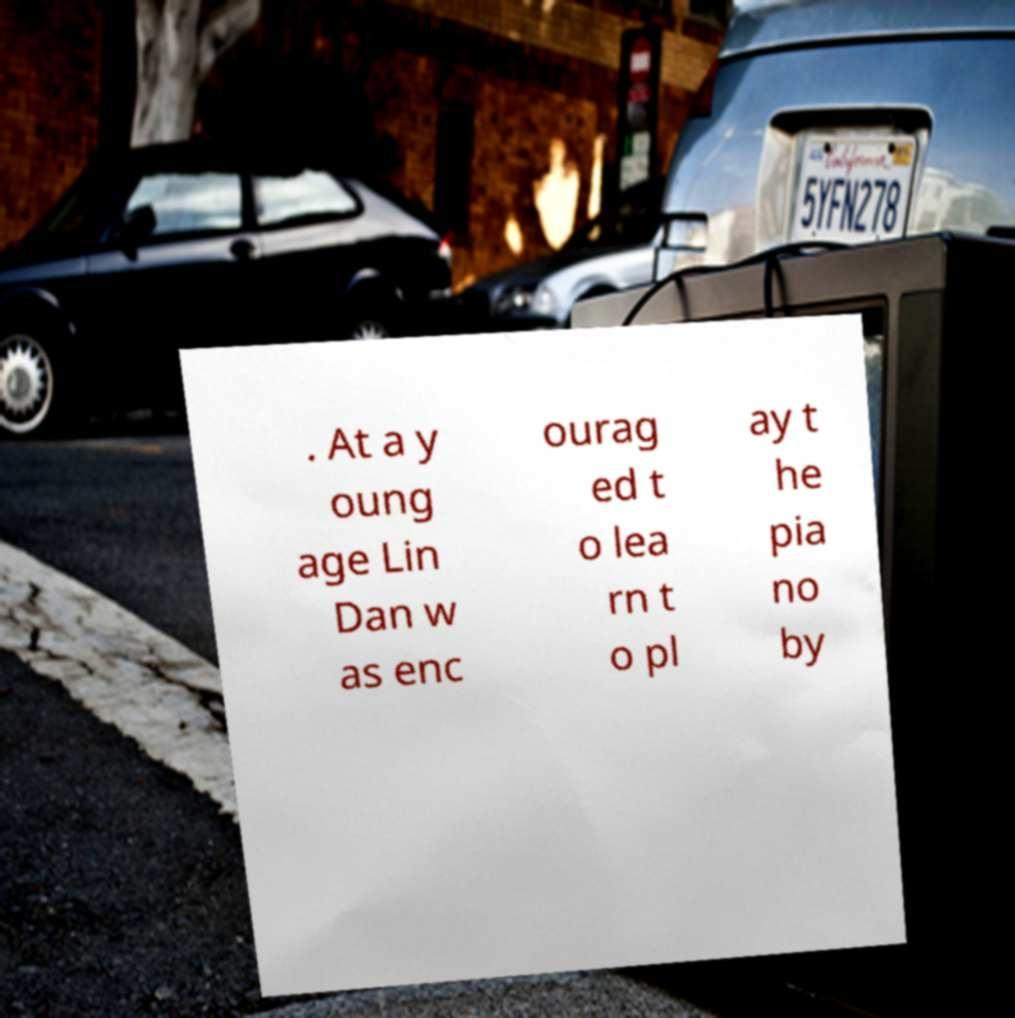There's text embedded in this image that I need extracted. Can you transcribe it verbatim? . At a y oung age Lin Dan w as enc ourag ed t o lea rn t o pl ay t he pia no by 